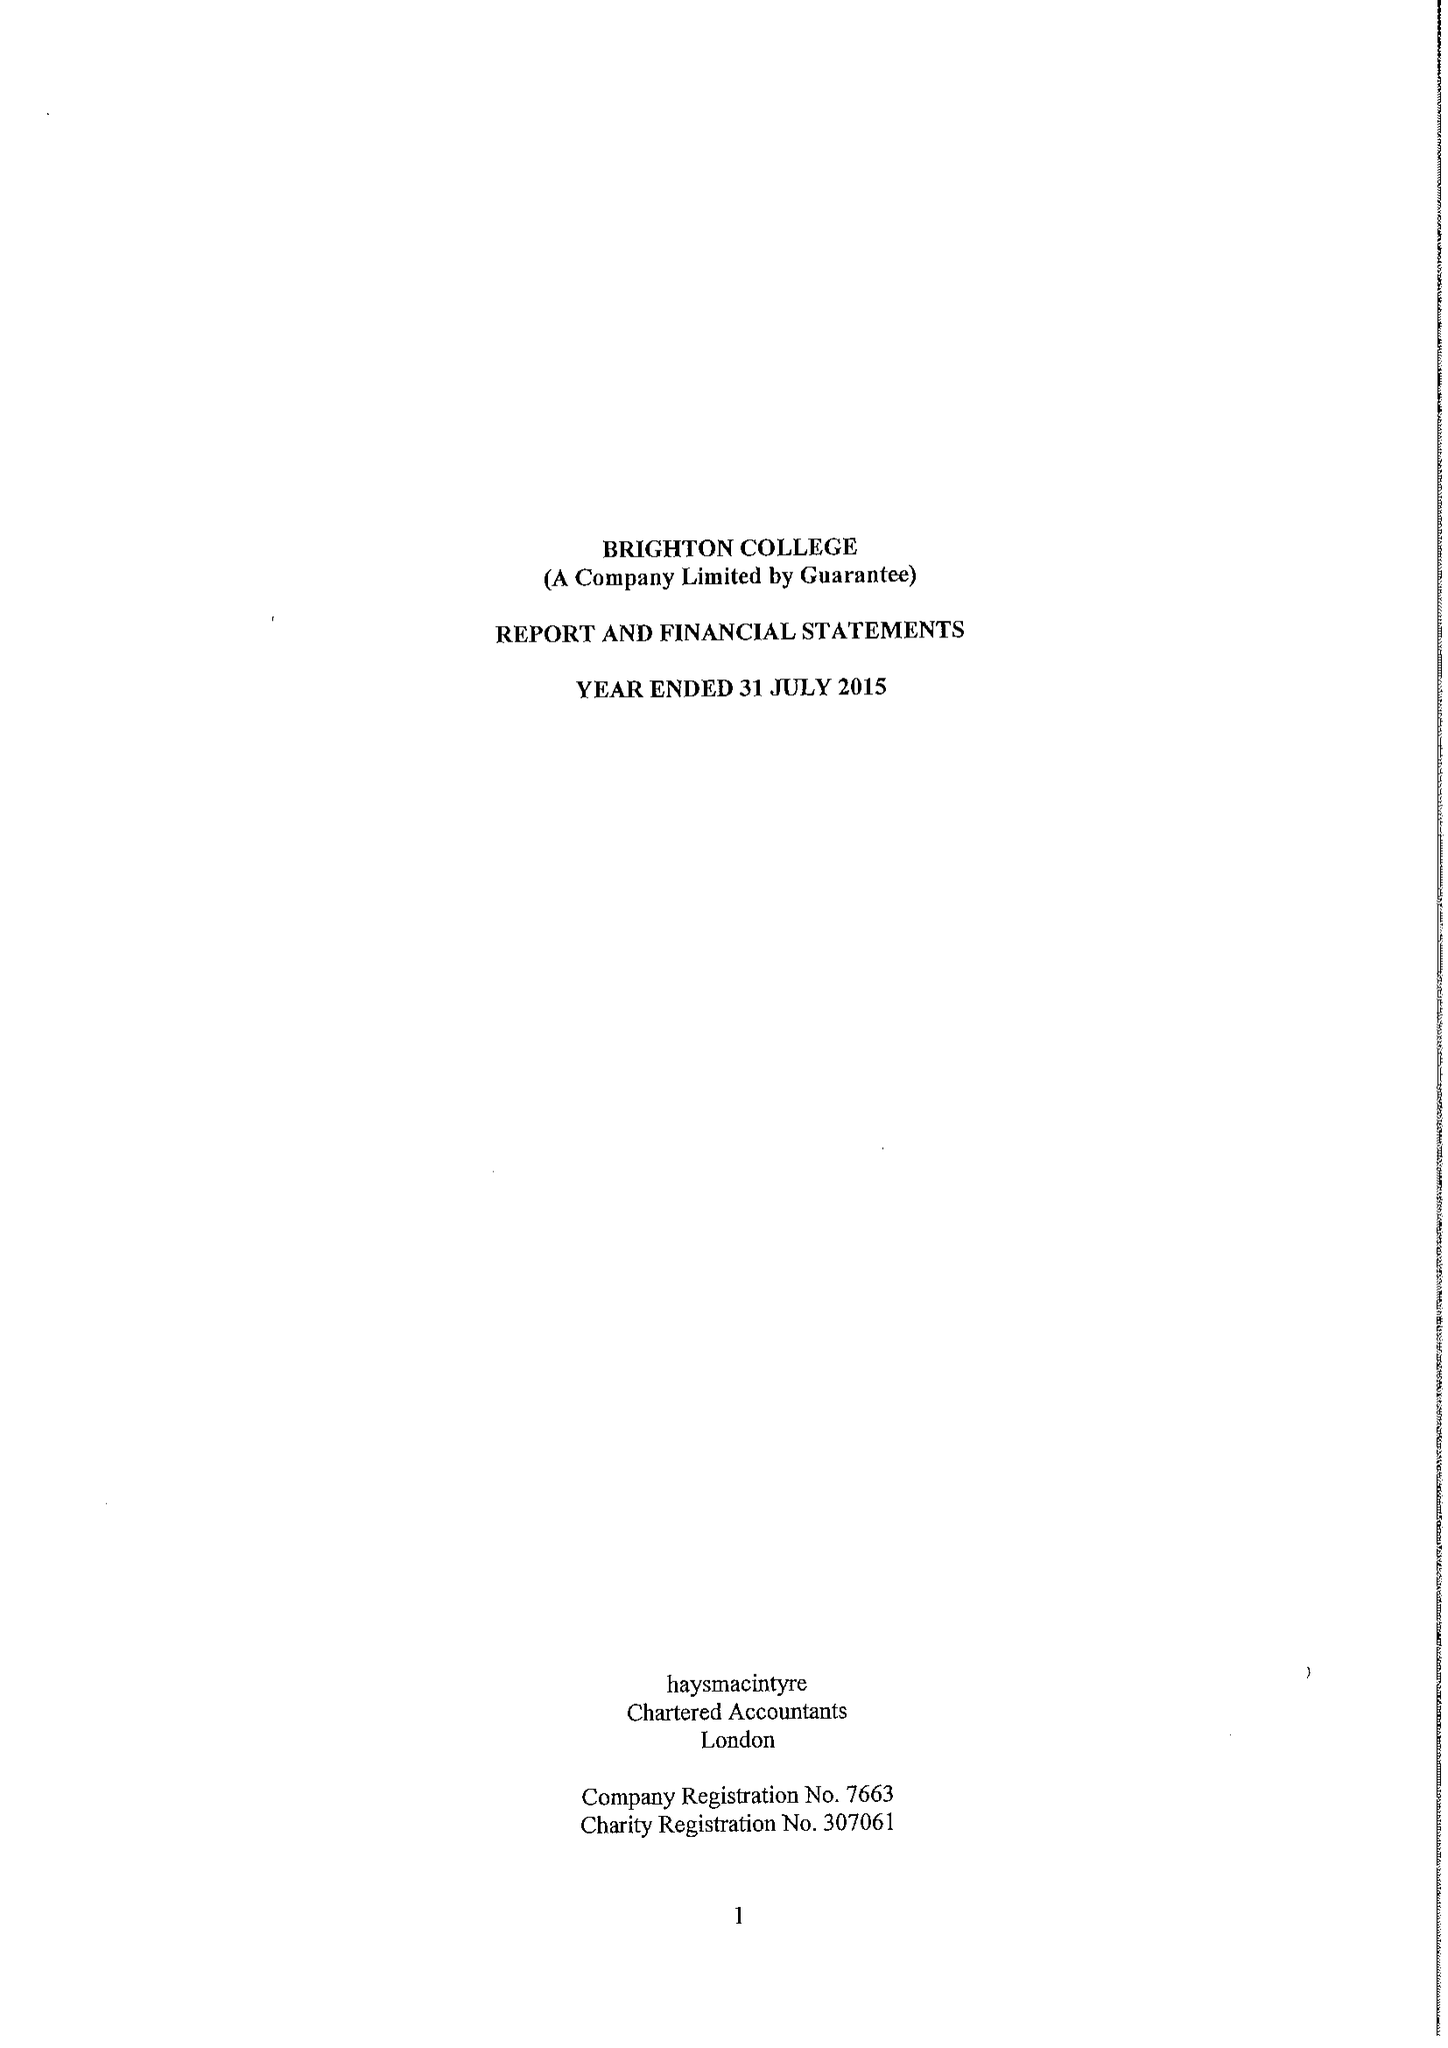What is the value for the address__street_line?
Answer the question using a single word or phrase. EASTERN ROAD 